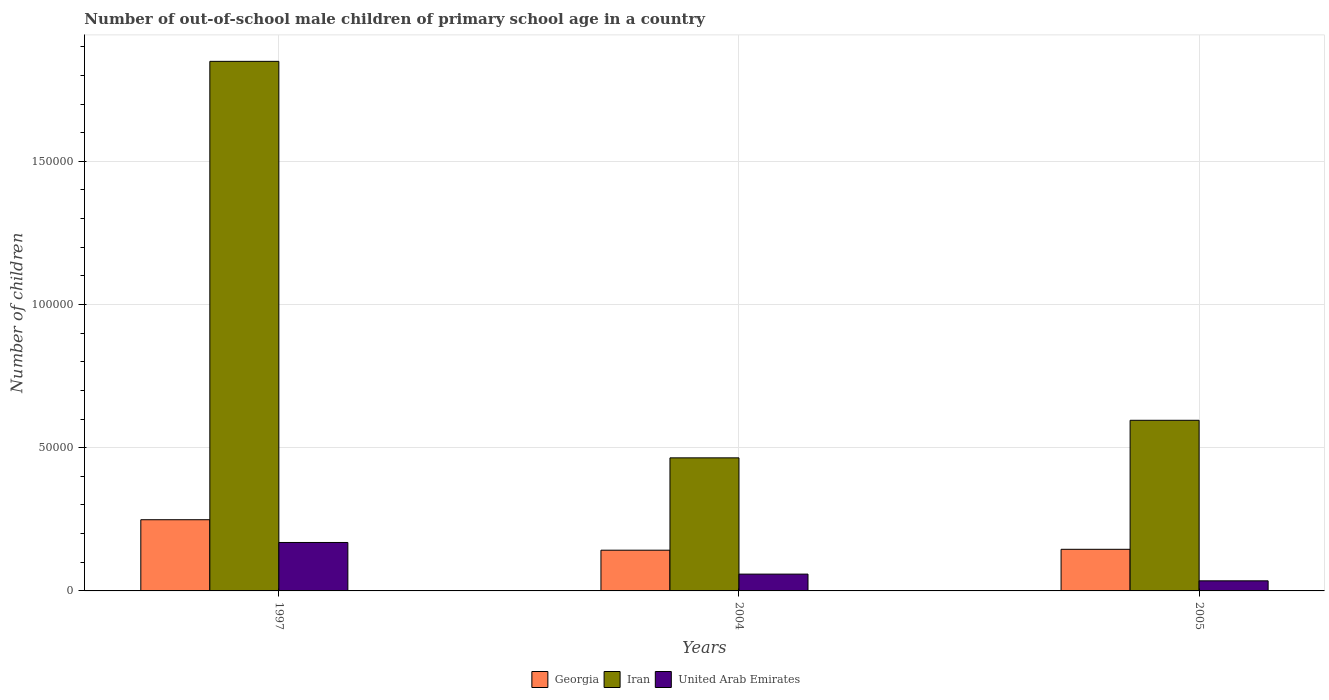How many groups of bars are there?
Make the answer very short. 3. Are the number of bars per tick equal to the number of legend labels?
Offer a terse response. Yes. Are the number of bars on each tick of the X-axis equal?
Provide a succinct answer. Yes. How many bars are there on the 3rd tick from the left?
Provide a short and direct response. 3. How many bars are there on the 3rd tick from the right?
Your response must be concise. 3. What is the label of the 3rd group of bars from the left?
Your response must be concise. 2005. In how many cases, is the number of bars for a given year not equal to the number of legend labels?
Your answer should be compact. 0. What is the number of out-of-school male children in United Arab Emirates in 2004?
Make the answer very short. 5868. Across all years, what is the maximum number of out-of-school male children in Georgia?
Keep it short and to the point. 2.49e+04. Across all years, what is the minimum number of out-of-school male children in United Arab Emirates?
Give a very brief answer. 3521. What is the total number of out-of-school male children in Iran in the graph?
Make the answer very short. 2.91e+05. What is the difference between the number of out-of-school male children in United Arab Emirates in 2004 and that in 2005?
Make the answer very short. 2347. What is the difference between the number of out-of-school male children in United Arab Emirates in 2005 and the number of out-of-school male children in Georgia in 2004?
Your response must be concise. -1.07e+04. What is the average number of out-of-school male children in Georgia per year?
Your response must be concise. 1.79e+04. In the year 2004, what is the difference between the number of out-of-school male children in Georgia and number of out-of-school male children in United Arab Emirates?
Your answer should be compact. 8350. In how many years, is the number of out-of-school male children in Georgia greater than 130000?
Ensure brevity in your answer.  0. What is the ratio of the number of out-of-school male children in Iran in 1997 to that in 2004?
Ensure brevity in your answer.  3.98. What is the difference between the highest and the second highest number of out-of-school male children in United Arab Emirates?
Offer a terse response. 1.10e+04. What is the difference between the highest and the lowest number of out-of-school male children in Georgia?
Offer a terse response. 1.06e+04. What does the 1st bar from the left in 2005 represents?
Ensure brevity in your answer.  Georgia. What does the 1st bar from the right in 1997 represents?
Give a very brief answer. United Arab Emirates. How many bars are there?
Offer a very short reply. 9. How many years are there in the graph?
Offer a terse response. 3. What is the difference between two consecutive major ticks on the Y-axis?
Make the answer very short. 5.00e+04. Are the values on the major ticks of Y-axis written in scientific E-notation?
Ensure brevity in your answer.  No. How many legend labels are there?
Ensure brevity in your answer.  3. How are the legend labels stacked?
Keep it short and to the point. Horizontal. What is the title of the graph?
Keep it short and to the point. Number of out-of-school male children of primary school age in a country. What is the label or title of the X-axis?
Your response must be concise. Years. What is the label or title of the Y-axis?
Your answer should be very brief. Number of children. What is the Number of children in Georgia in 1997?
Your response must be concise. 2.49e+04. What is the Number of children of Iran in 1997?
Provide a short and direct response. 1.85e+05. What is the Number of children in United Arab Emirates in 1997?
Give a very brief answer. 1.69e+04. What is the Number of children of Georgia in 2004?
Offer a terse response. 1.42e+04. What is the Number of children of Iran in 2004?
Give a very brief answer. 4.65e+04. What is the Number of children of United Arab Emirates in 2004?
Your answer should be very brief. 5868. What is the Number of children in Georgia in 2005?
Offer a terse response. 1.45e+04. What is the Number of children in Iran in 2005?
Ensure brevity in your answer.  5.96e+04. What is the Number of children of United Arab Emirates in 2005?
Keep it short and to the point. 3521. Across all years, what is the maximum Number of children in Georgia?
Your response must be concise. 2.49e+04. Across all years, what is the maximum Number of children of Iran?
Provide a succinct answer. 1.85e+05. Across all years, what is the maximum Number of children of United Arab Emirates?
Provide a short and direct response. 1.69e+04. Across all years, what is the minimum Number of children in Georgia?
Make the answer very short. 1.42e+04. Across all years, what is the minimum Number of children in Iran?
Provide a short and direct response. 4.65e+04. Across all years, what is the minimum Number of children in United Arab Emirates?
Provide a short and direct response. 3521. What is the total Number of children in Georgia in the graph?
Your answer should be compact. 5.36e+04. What is the total Number of children in Iran in the graph?
Keep it short and to the point. 2.91e+05. What is the total Number of children of United Arab Emirates in the graph?
Your response must be concise. 2.63e+04. What is the difference between the Number of children in Georgia in 1997 and that in 2004?
Keep it short and to the point. 1.06e+04. What is the difference between the Number of children in Iran in 1997 and that in 2004?
Offer a very short reply. 1.38e+05. What is the difference between the Number of children of United Arab Emirates in 1997 and that in 2004?
Provide a succinct answer. 1.10e+04. What is the difference between the Number of children of Georgia in 1997 and that in 2005?
Give a very brief answer. 1.03e+04. What is the difference between the Number of children of Iran in 1997 and that in 2005?
Make the answer very short. 1.25e+05. What is the difference between the Number of children in United Arab Emirates in 1997 and that in 2005?
Give a very brief answer. 1.34e+04. What is the difference between the Number of children in Georgia in 2004 and that in 2005?
Make the answer very short. -311. What is the difference between the Number of children in Iran in 2004 and that in 2005?
Offer a terse response. -1.31e+04. What is the difference between the Number of children of United Arab Emirates in 2004 and that in 2005?
Keep it short and to the point. 2347. What is the difference between the Number of children in Georgia in 1997 and the Number of children in Iran in 2004?
Keep it short and to the point. -2.16e+04. What is the difference between the Number of children in Georgia in 1997 and the Number of children in United Arab Emirates in 2004?
Make the answer very short. 1.90e+04. What is the difference between the Number of children of Iran in 1997 and the Number of children of United Arab Emirates in 2004?
Your response must be concise. 1.79e+05. What is the difference between the Number of children in Georgia in 1997 and the Number of children in Iran in 2005?
Your answer should be compact. -3.47e+04. What is the difference between the Number of children in Georgia in 1997 and the Number of children in United Arab Emirates in 2005?
Your answer should be compact. 2.13e+04. What is the difference between the Number of children in Iran in 1997 and the Number of children in United Arab Emirates in 2005?
Your answer should be very brief. 1.81e+05. What is the difference between the Number of children in Georgia in 2004 and the Number of children in Iran in 2005?
Your answer should be very brief. -4.54e+04. What is the difference between the Number of children in Georgia in 2004 and the Number of children in United Arab Emirates in 2005?
Offer a very short reply. 1.07e+04. What is the difference between the Number of children in Iran in 2004 and the Number of children in United Arab Emirates in 2005?
Offer a terse response. 4.29e+04. What is the average Number of children of Georgia per year?
Provide a succinct answer. 1.79e+04. What is the average Number of children of Iran per year?
Provide a short and direct response. 9.70e+04. What is the average Number of children in United Arab Emirates per year?
Your answer should be very brief. 8768. In the year 1997, what is the difference between the Number of children in Georgia and Number of children in Iran?
Give a very brief answer. -1.60e+05. In the year 1997, what is the difference between the Number of children of Georgia and Number of children of United Arab Emirates?
Give a very brief answer. 7942. In the year 1997, what is the difference between the Number of children in Iran and Number of children in United Arab Emirates?
Ensure brevity in your answer.  1.68e+05. In the year 2004, what is the difference between the Number of children in Georgia and Number of children in Iran?
Make the answer very short. -3.22e+04. In the year 2004, what is the difference between the Number of children in Georgia and Number of children in United Arab Emirates?
Give a very brief answer. 8350. In the year 2004, what is the difference between the Number of children in Iran and Number of children in United Arab Emirates?
Your answer should be compact. 4.06e+04. In the year 2005, what is the difference between the Number of children in Georgia and Number of children in Iran?
Ensure brevity in your answer.  -4.50e+04. In the year 2005, what is the difference between the Number of children of Georgia and Number of children of United Arab Emirates?
Offer a very short reply. 1.10e+04. In the year 2005, what is the difference between the Number of children in Iran and Number of children in United Arab Emirates?
Your answer should be very brief. 5.61e+04. What is the ratio of the Number of children in Georgia in 1997 to that in 2004?
Give a very brief answer. 1.75. What is the ratio of the Number of children in Iran in 1997 to that in 2004?
Offer a terse response. 3.98. What is the ratio of the Number of children of United Arab Emirates in 1997 to that in 2004?
Offer a terse response. 2.88. What is the ratio of the Number of children in Georgia in 1997 to that in 2005?
Provide a short and direct response. 1.71. What is the ratio of the Number of children of Iran in 1997 to that in 2005?
Make the answer very short. 3.1. What is the ratio of the Number of children of United Arab Emirates in 1997 to that in 2005?
Your answer should be very brief. 4.8. What is the ratio of the Number of children of Georgia in 2004 to that in 2005?
Offer a terse response. 0.98. What is the ratio of the Number of children of Iran in 2004 to that in 2005?
Offer a very short reply. 0.78. What is the ratio of the Number of children in United Arab Emirates in 2004 to that in 2005?
Make the answer very short. 1.67. What is the difference between the highest and the second highest Number of children of Georgia?
Offer a terse response. 1.03e+04. What is the difference between the highest and the second highest Number of children in Iran?
Provide a short and direct response. 1.25e+05. What is the difference between the highest and the second highest Number of children of United Arab Emirates?
Make the answer very short. 1.10e+04. What is the difference between the highest and the lowest Number of children of Georgia?
Your response must be concise. 1.06e+04. What is the difference between the highest and the lowest Number of children in Iran?
Offer a very short reply. 1.38e+05. What is the difference between the highest and the lowest Number of children in United Arab Emirates?
Make the answer very short. 1.34e+04. 